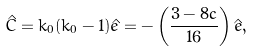Convert formula to latex. <formula><loc_0><loc_0><loc_500><loc_500>\hat { C } = k _ { 0 } ( k _ { 0 } - 1 ) \hat { e } = - \left ( \frac { 3 - 8 c } { 1 6 } \right ) \hat { e } ,</formula> 